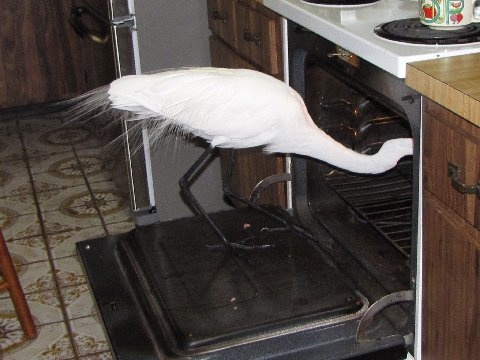Describe the objects in this image and their specific colors. I can see oven in black and gray tones, bird in black, lightgray, darkgray, and gray tones, refrigerator in black, gray, and darkgray tones, cup in black, beige, darkgray, and teal tones, and chair in black, maroon, and gray tones in this image. 